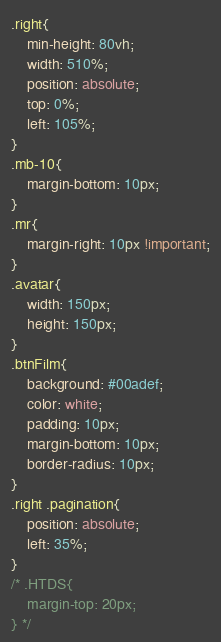Convert code to text. <code><loc_0><loc_0><loc_500><loc_500><_CSS_>.right{
    min-height: 80vh;
    width: 510%;
    position: absolute;
    top: 0%;
    left: 105%;
}
.mb-10{
    margin-bottom: 10px;
}
.mr{
    margin-right: 10px !important;
}
.avatar{
    width: 150px;
    height: 150px;
}
.btnFilm{
    background: #00adef;
    color: white;
    padding: 10px;
    margin-bottom: 10px;
    border-radius: 10px;
}
.right .pagination{
    position: absolute;
    left: 35%;
}
/* .HTDS{
    margin-top: 20px;
} */</code> 